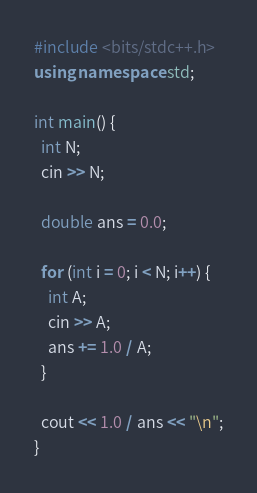<code> <loc_0><loc_0><loc_500><loc_500><_C++_>#include <bits/stdc++.h>
using namespace std;

int main() {
  int N;
  cin >> N;

  double ans = 0.0;

  for (int i = 0; i < N; i++) {
    int A;
    cin >> A;
    ans += 1.0 / A;
  }

  cout << 1.0 / ans << "\n";
}</code> 